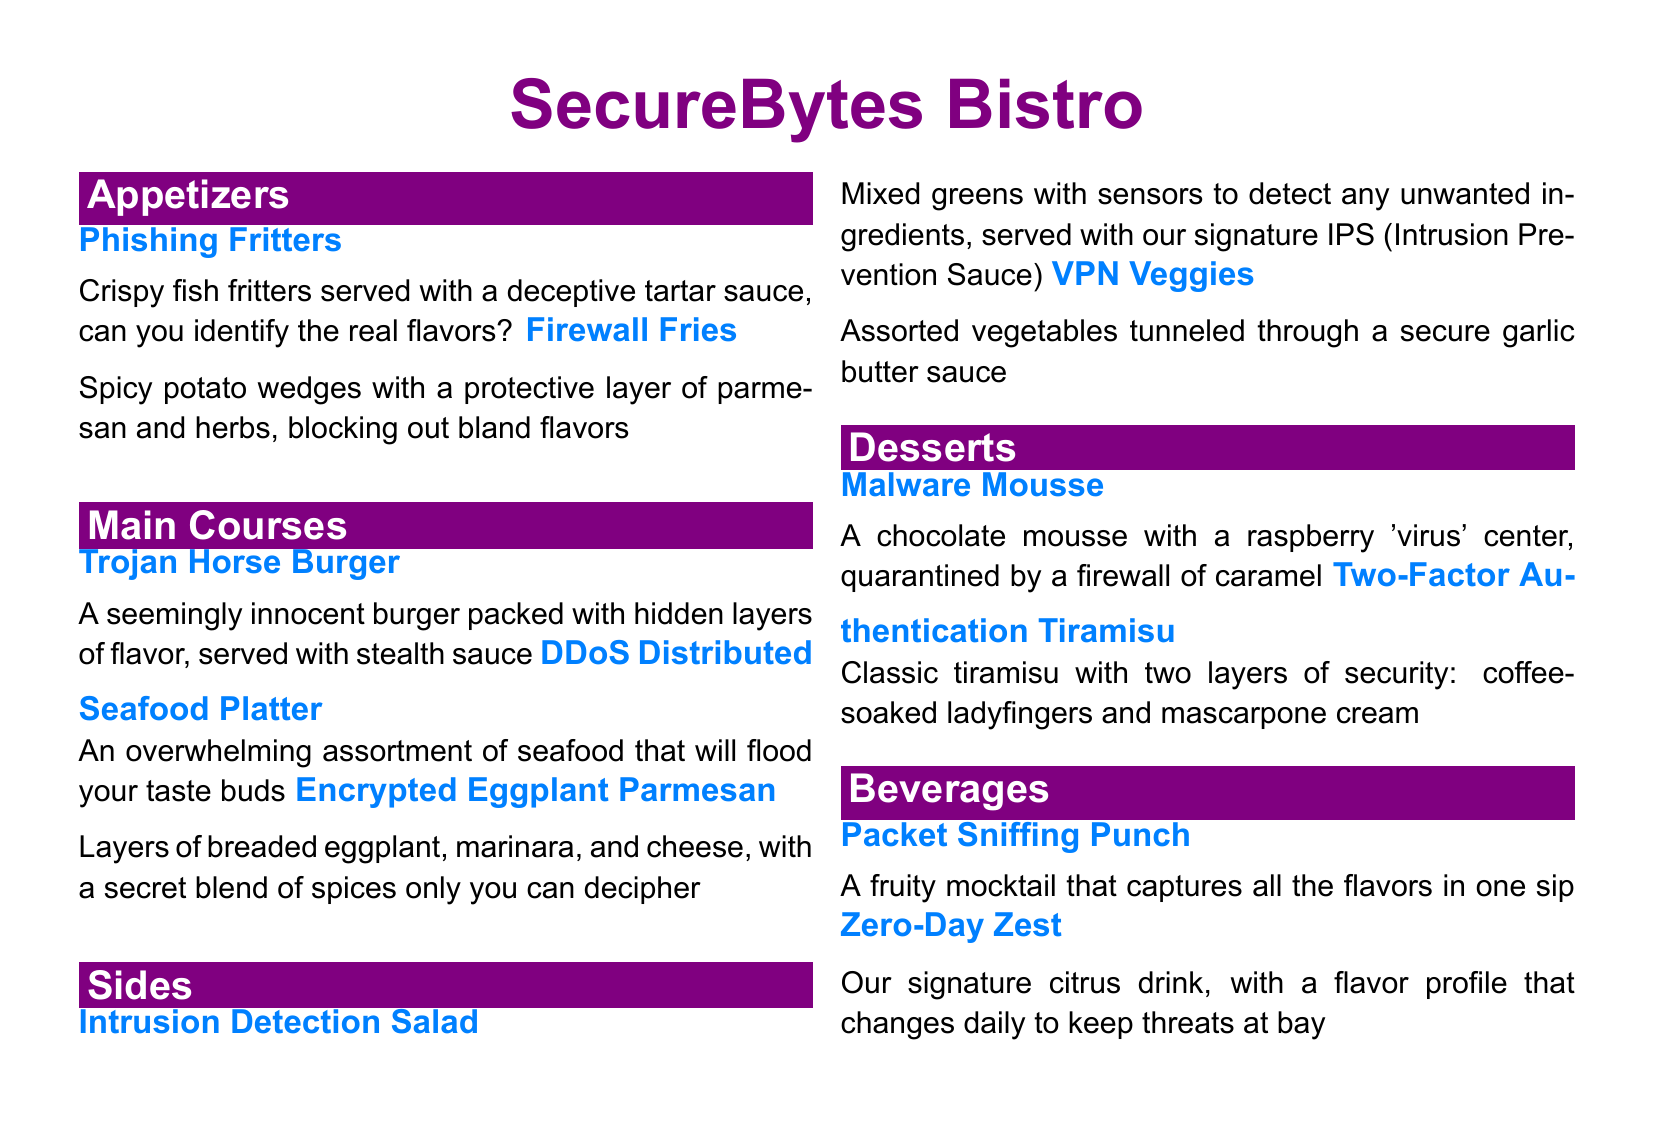What is the name of the restaurant? The name of the restaurant is prominently displayed at the top of the menu.
Answer: SecureBytes Bistro How many main courses are listed on the menu? The total number of main courses listed can be counted within the sections of the menu.
Answer: 3 What is the first appetizer on the menu? The first appetizer is listed at the top of the appetizers section.
Answer: Phishing Fritters What dessert has a raspberry center? The dessert featuring a raspberry center is described in the dessert section of the menu.
Answer: Malware Mousse Which beverage has a daily changing flavor? The beverage with a flavor profile that changes daily is explicitly mentioned in the beverages section.
Answer: Zero-Day Zest What is the protective sauce served with the Firewall Fries? The sauce that accompanies the Firewall Fries is specified in the description of that dish.
Answer: Parmesan and herbs How many desserts are offered in total? The desserts can be counted from the desserts section of the menu to determine the total.
Answer: 2 What is the main ingredient in the Trojan Horse Burger? The main ingredient of the Trojan Horse Burger is inferred from the name and description given.
Answer: Burger What does the Intrusion Detection Salad detect? The salad's function is clearly outlined in its description.
Answer: Unwanted ingredients What is the acronym for Intrusion Prevention Sauce? The sauce's abbreviation is presented along with the dish description.
Answer: IPS 